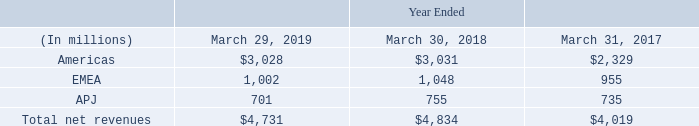Geographical information
Net revenues by geography are based on the billing addresses of our customers. The following table represents net revenues by geographic area for the periods presented:
Note: The Americas include U.S., Canada, and Latin America; EMEA includes Europe, Middle East, and Africa; APJ includes Asia Pacific and Japan
Revenues from customers inside the U.S. were $2.8 billion, $2.8 billion, and $2.1 billion during fiscal 2019, 2018, and 2017, respectively. No other individual country accounted for more than 10% of revenues.
What is the revenue from customers inside the U.S. in fiscal 2019? $2.8 billion. What are the regions included in the table? Americas, emea, apj. What areas are included in the Americas? U.s., canada, and latin america. What is the average revenue from customers inside the U.S. for fiscal years 2019, 2018 and 2017? 
Answer scale should be: billion. (2.8+2.8+2.1)/3
Answer: 2.57. What is the Revenues from customers inside the U.S. expressed as a percentage of Total net revenues for 2019?
Answer scale should be: percent. 2.8 billion /4,731 million
Answer: 59.18. What is the average Total net revenues for fiscal years 2019, 2018 and 2017?
Answer scale should be: million. (4,731+4,834+4,019)/3
Answer: 4528. 